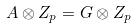<formula> <loc_0><loc_0><loc_500><loc_500>A \otimes Z _ { p } = G \otimes Z _ { p }</formula> 